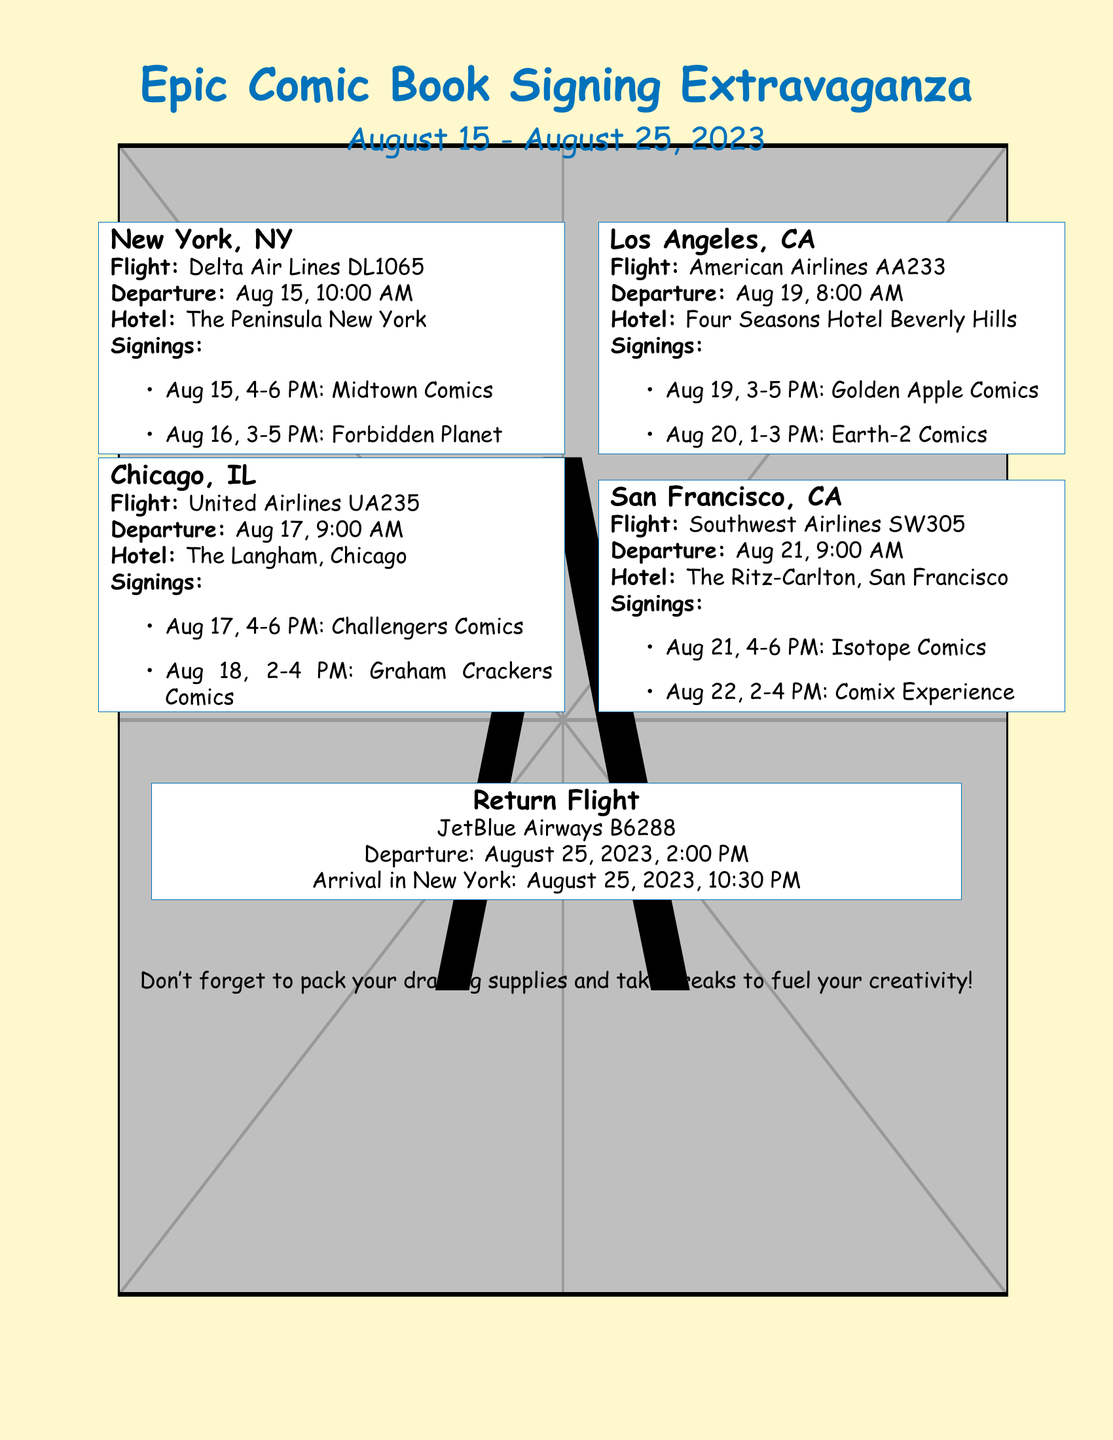What is the departure date for New York? The departure date for New York is specified in the flight section of the document.
Answer: August 15, 2023 Where is the first hotel booked? The document lists the first hotel booked under the New York ticket box.
Answer: The Peninsula New York What time is the signing at Midtown Comics? The signing time is provided under the New York section and specifies the time for the event.
Answer: 4-6 PM Which airline is used for the return flight? The return flight details are provided at the end of the document, specifying the airline for that flight.
Answer: JetBlue Airways How many comic store visits are scheduled in Chicago? The document includes a list of signings, which indicates the number of events scheduled for that location.
Answer: 2 What is the address of the last signing in San Francisco? The document lists signings by name, while the specific addresses might be inferred or understood contextually.
Answer: Comix Experience What time is the flight from Los Angeles? The flight time is presented in the Los Angeles ticket box, specifying the details.
Answer: 8:00 AM Which city is planned for signings on August 20? The document indicates the signing schedule by date and identifies the associated city from the context.
Answer: Los Angeles 